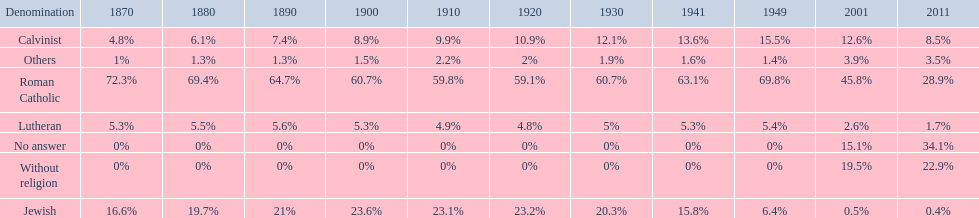Which denomination percentage increased the most after 1949? Without religion. 